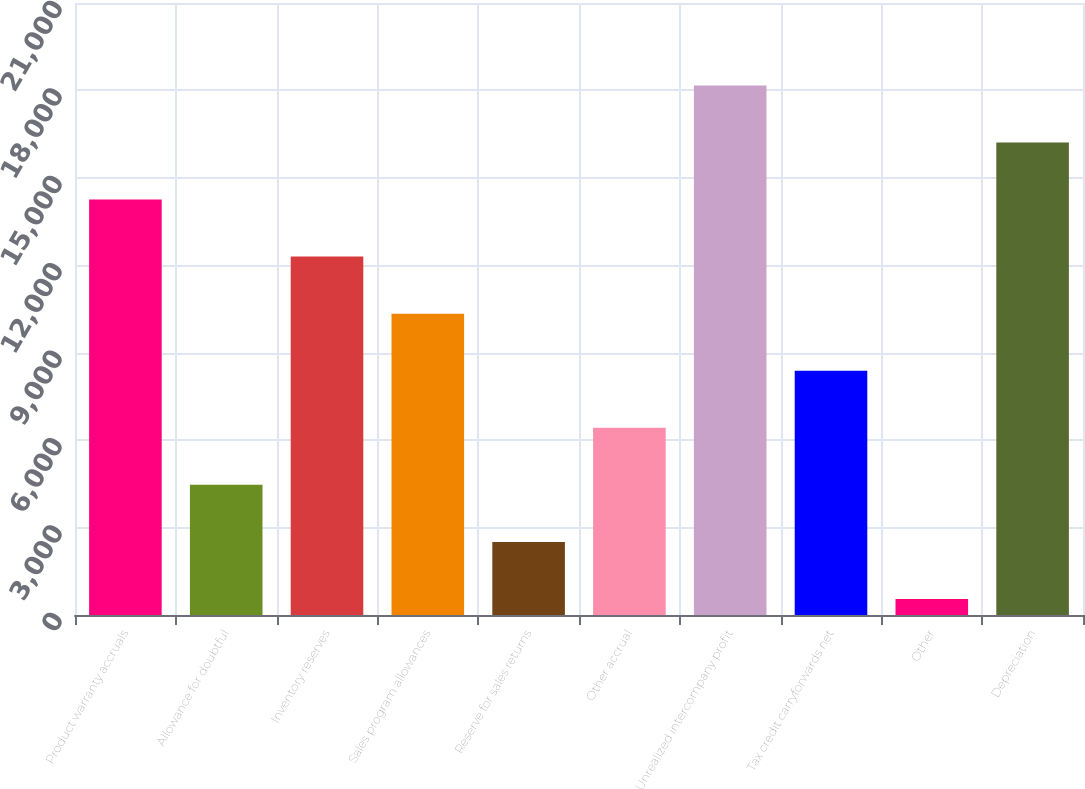<chart> <loc_0><loc_0><loc_500><loc_500><bar_chart><fcel>Product warranty accruals<fcel>Allowance for doubtful<fcel>Inventory reserves<fcel>Sales program allowances<fcel>Reserve for sales returns<fcel>Other accrual<fcel>Unrealized intercompany profit<fcel>Tax credit carryforwards net<fcel>Other<fcel>Depreciation<nl><fcel>14255.3<fcel>4465.8<fcel>12297.4<fcel>10339.5<fcel>2507.9<fcel>6423.7<fcel>18171.1<fcel>8381.6<fcel>550<fcel>16213.2<nl></chart> 